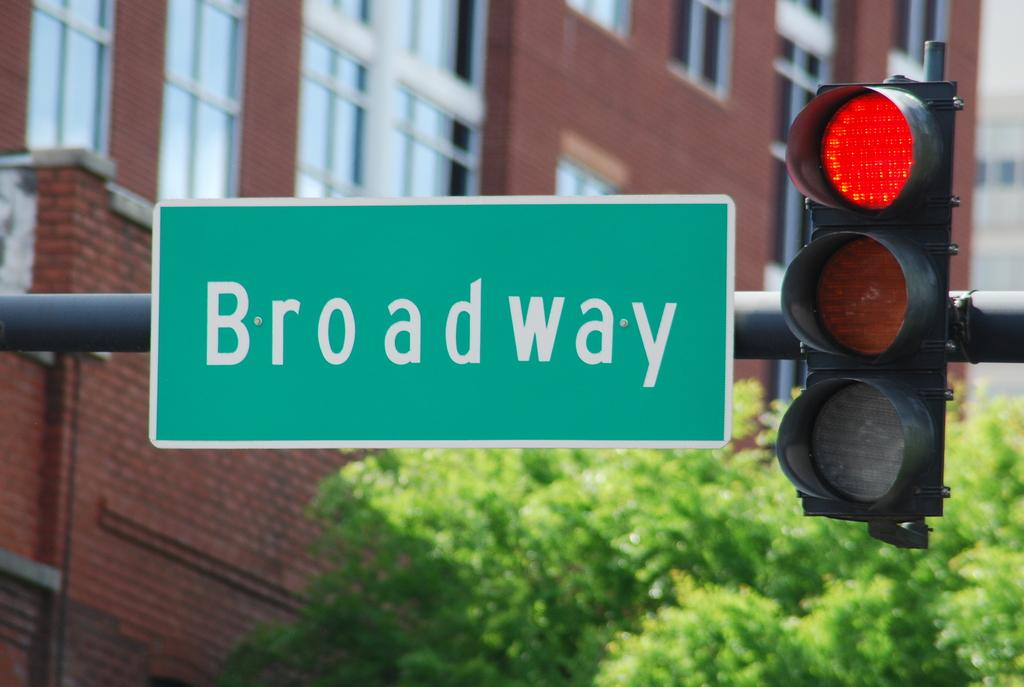<image>
Relay a brief, clear account of the picture shown. Street sign that says Broadway next to a traffic light. 